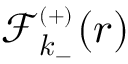Convert formula to latex. <formula><loc_0><loc_0><loc_500><loc_500>{ \mathcal { F } _ { k _ { - } } ^ { _ { ( + ) } } ( r ) }</formula> 